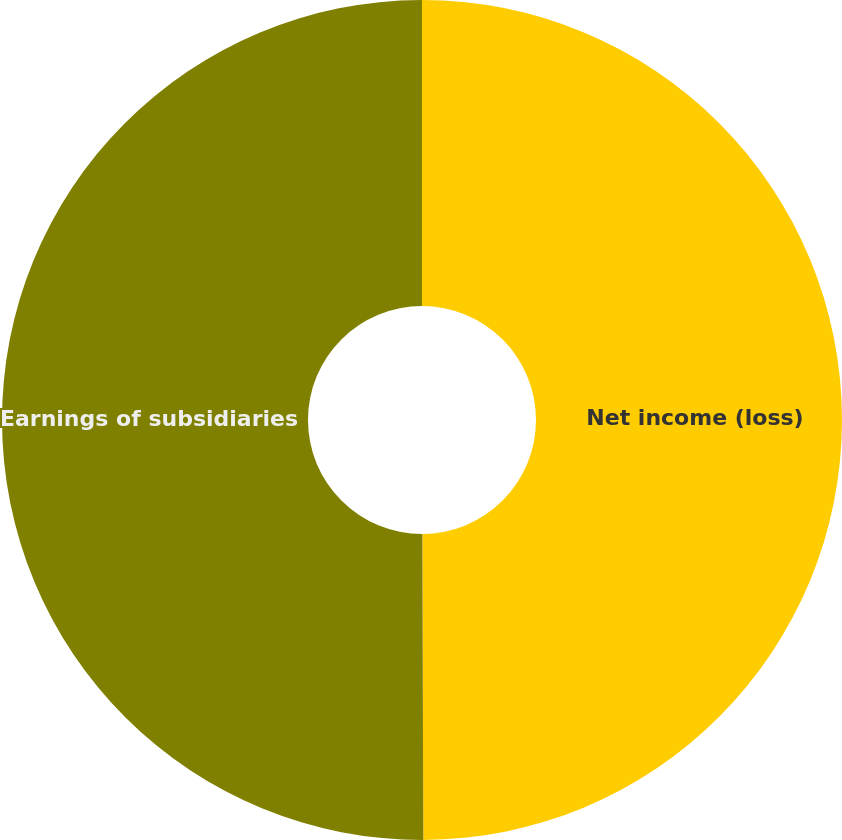<chart> <loc_0><loc_0><loc_500><loc_500><pie_chart><fcel>Net income (loss)<fcel>Earnings of subsidiaries<nl><fcel>49.95%<fcel>50.05%<nl></chart> 